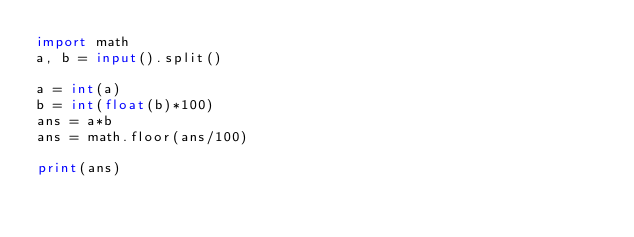<code> <loc_0><loc_0><loc_500><loc_500><_Python_>import math
a, b = input().split()

a = int(a)
b = int(float(b)*100)
ans = a*b
ans = math.floor(ans/100)

print(ans)
</code> 